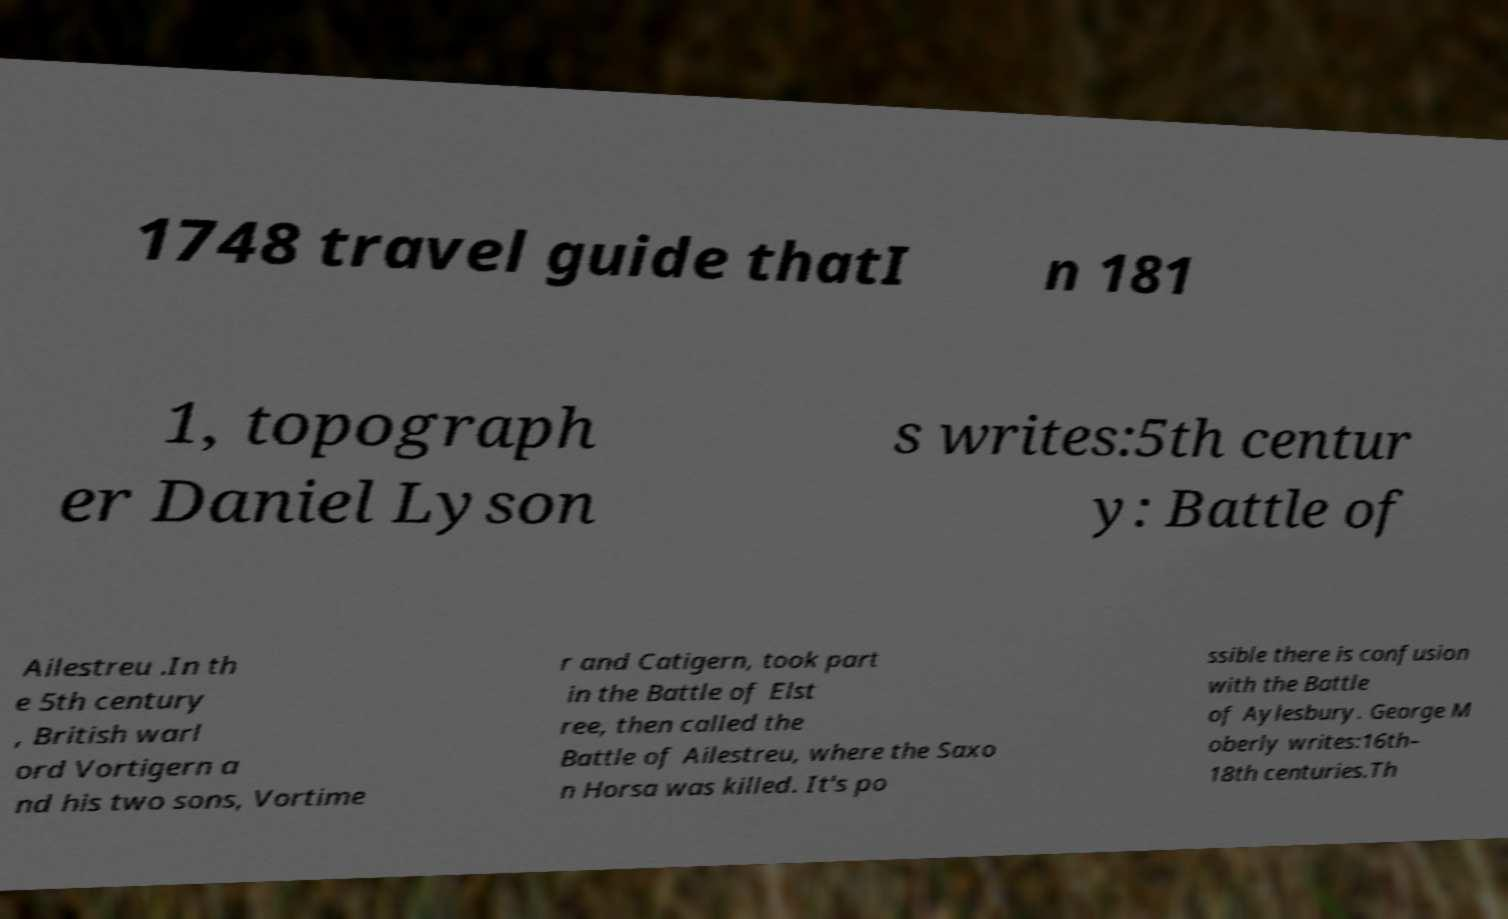For documentation purposes, I need the text within this image transcribed. Could you provide that? 1748 travel guide thatI n 181 1, topograph er Daniel Lyson s writes:5th centur y: Battle of Ailestreu .In th e 5th century , British warl ord Vortigern a nd his two sons, Vortime r and Catigern, took part in the Battle of Elst ree, then called the Battle of Ailestreu, where the Saxo n Horsa was killed. It's po ssible there is confusion with the Battle of Aylesbury. George M oberly writes:16th– 18th centuries.Th 